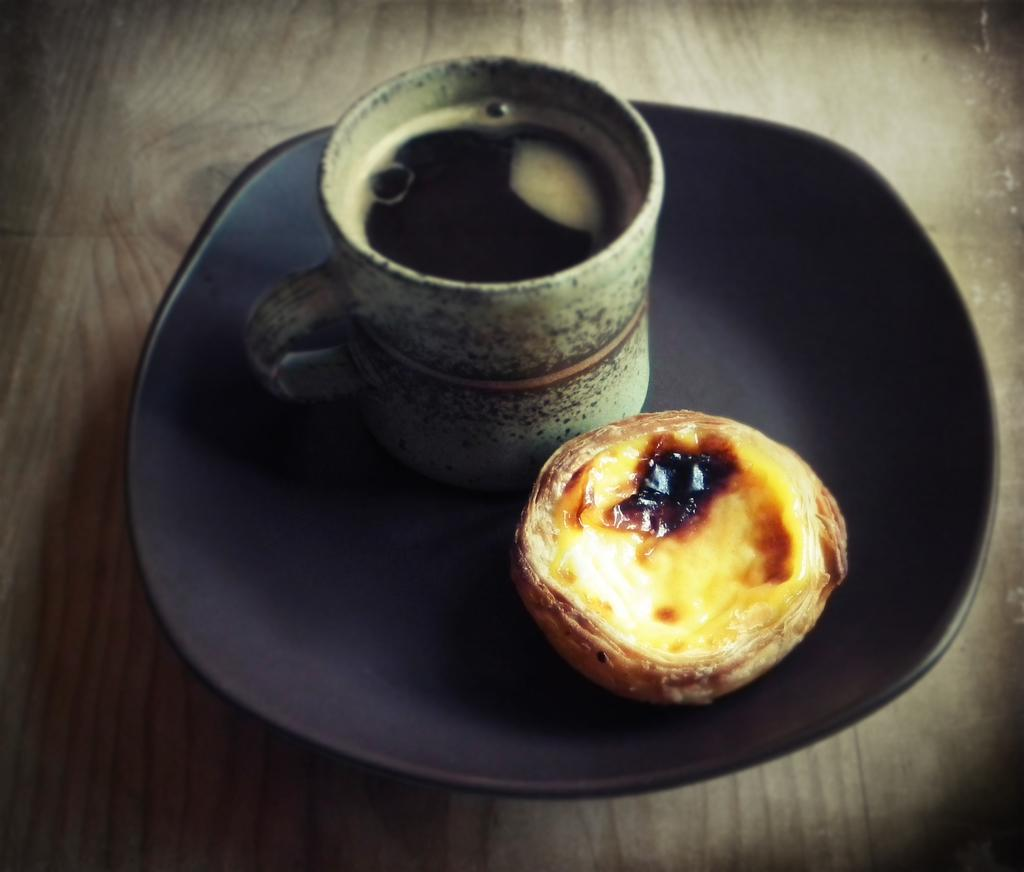What is in the cup that is visible in the image? There is a cup with liquid in the image. What is on the plate that is visible in the image? There is a plate with a food item in the image. Where are the cup and plate located in the image? Both the cup and plate are on a platform. What type of game is being played on the platform in the image? There is no game present in the image; it only features a cup with liquid and a plate with a food item on a platform. 